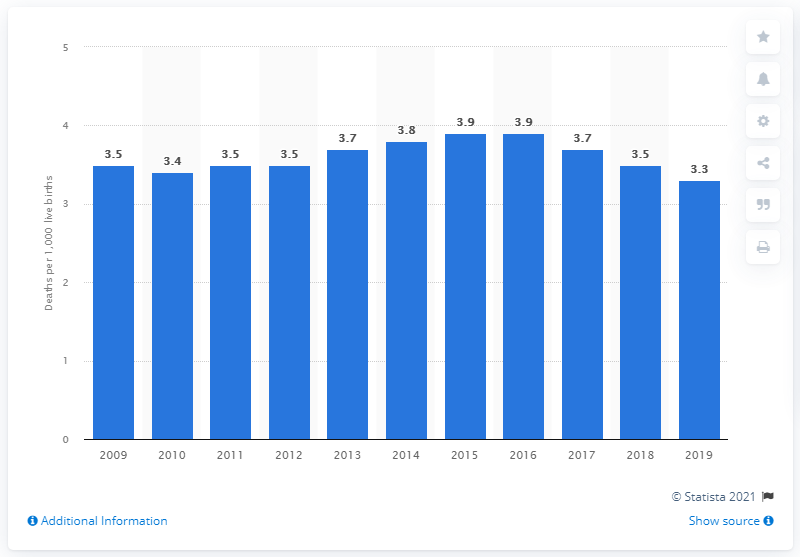Draw attention to some important aspects in this diagram. In 2019, the infant mortality rate in Greece was 3.3. 